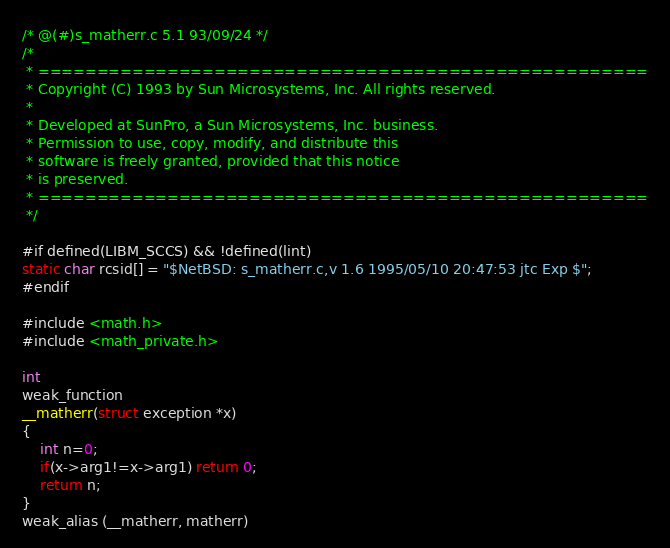<code> <loc_0><loc_0><loc_500><loc_500><_C_>/* @(#)s_matherr.c 5.1 93/09/24 */
/*
 * ====================================================
 * Copyright (C) 1993 by Sun Microsystems, Inc. All rights reserved.
 *
 * Developed at SunPro, a Sun Microsystems, Inc. business.
 * Permission to use, copy, modify, and distribute this
 * software is freely granted, provided that this notice
 * is preserved.
 * ====================================================
 */

#if defined(LIBM_SCCS) && !defined(lint)
static char rcsid[] = "$NetBSD: s_matherr.c,v 1.6 1995/05/10 20:47:53 jtc Exp $";
#endif

#include <math.h>
#include <math_private.h>

int
weak_function
__matherr(struct exception *x)
{
	int n=0;
	if(x->arg1!=x->arg1) return 0;
	return n;
}
weak_alias (__matherr, matherr)
</code> 